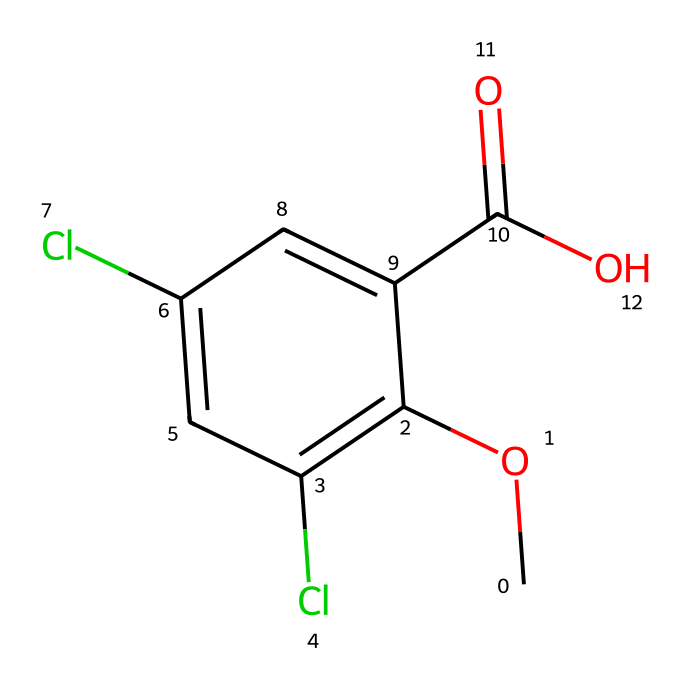What is the molecular formula of dicamba? The SMILES representation indicates the presence of carbon (C), hydrogen (H), chlorine (Cl), and oxygen (O) atoms. By counting the atoms indicated in the SMILES, we can derive the molecular formula C8H6Cl2O3.
Answer: C8H6Cl2O3 How many chlorine atoms are present in dicamba? In the provided SMILES, the appearance of "Cl" indicates the presence of chlorine atoms. By checking its occurrences, we can see that there are two "Cl" atoms present.
Answer: 2 What functional group is present in dicamba that contributes to its acidic properties? The presence of the "C(=O)O" segment indicates a carboxylic acid group, which is known for contributing acidic properties.
Answer: carboxylic acid What type of herbicide is dicamba primarily classified as? Dicamba is categorized as a phenoxy herbicide and is primarily used to target broadleaf weeds.
Answer: phenoxy How many rings are present in the chemical structure of dicamba? By examining the SMILES representation, we can identify an aromatic ring structure indicated by "c" (representing aromatic carbon). There is one aromatic ring present in dicamba.
Answer: 1 Which part of the dicamba structure is responsible for its herbicidal activity? The presence of the aromatic ring combined with the carboxylic group contributes to the herbicidal activity. The chlorine substitutions on the ring enhance its effectiveness against target weeds.
Answer: aromatic ring and carboxylic group 